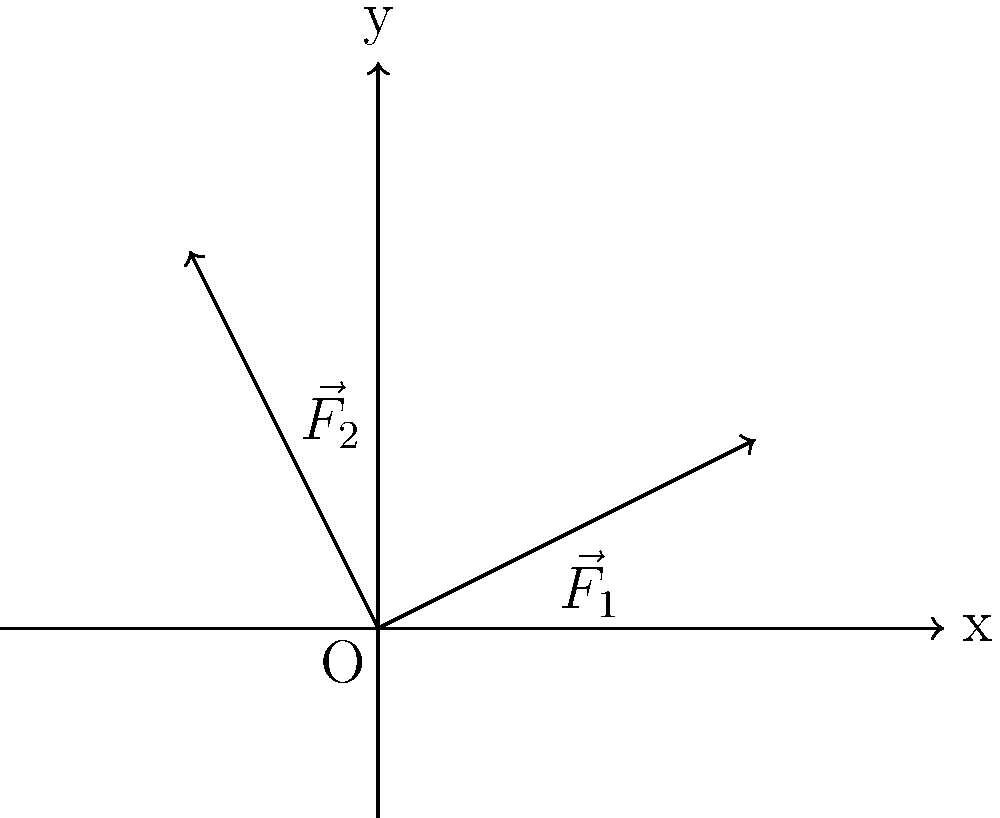During a political handshake, two opposing forces act on a politician's arm as shown in the vector diagram. $\vec{F}_1$ represents the force exerted by the politician, while $\vec{F}_2$ represents the force from the other person. If $\vec{F}_1 = 2\hat{i} + \hat{j}$ and $\vec{F}_2 = -\hat{i} + 2\hat{j}$, what is the magnitude of the resultant force on the politician's arm? To find the magnitude of the resultant force, we need to follow these steps:

1. Determine the resultant force vector by adding the two force vectors:
   $\vec{F}_R = \vec{F}_1 + \vec{F}_2$
   
2. Add the components:
   $\vec{F}_R = (2\hat{i} + \hat{j}) + (-\hat{i} + 2\hat{j})$
   $\vec{F}_R = (2-1)\hat{i} + (1+2)\hat{j}$
   $\vec{F}_R = \hat{i} + 3\hat{j}$

3. Calculate the magnitude of the resultant force using the Pythagorean theorem:
   $|\vec{F}_R| = \sqrt{(1)^2 + (3)^2}$
   $|\vec{F}_R| = \sqrt{1 + 9}$
   $|\vec{F}_R| = \sqrt{10}$

Therefore, the magnitude of the resultant force on the politician's arm is $\sqrt{10}$ units.
Answer: $\sqrt{10}$ units 